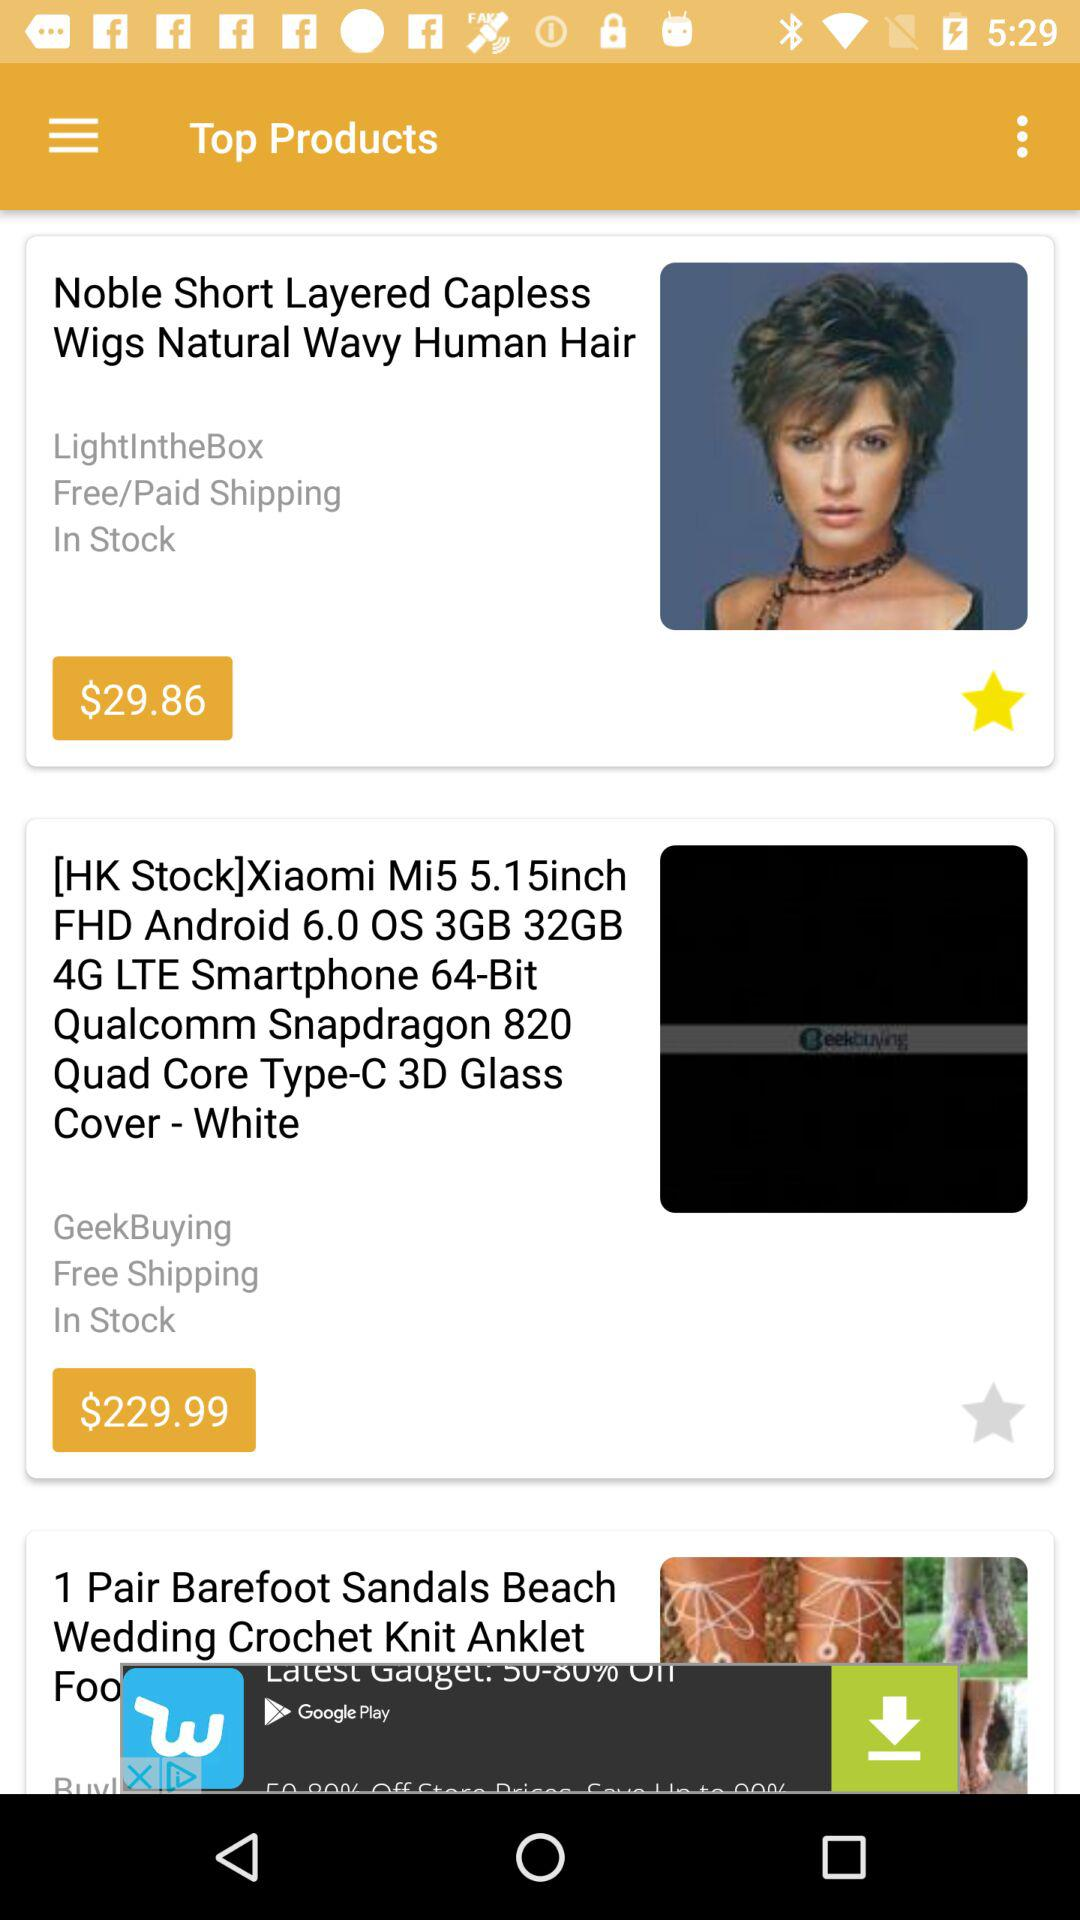Which are the different top products? The different top products are "Noble Short Layered Capless Wigs Natural Wavy Human Hair" and "[HK Stock]Xiaomi Mi5 5.15inch FHD Android 6.0 OS 3GB 32GB 4G LTE Smartphone 64-Bit Qualcomm Snapdragon 820 Quad Core Type-C 3D Glass Cover - White". 